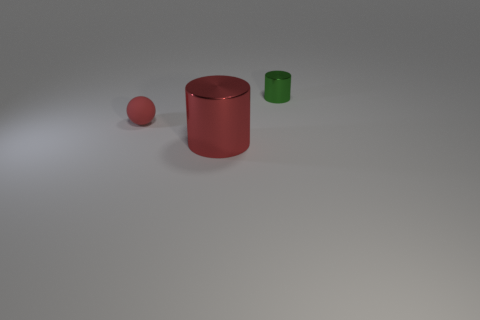Add 1 big red things. How many objects exist? 4 Subtract all spheres. How many objects are left? 2 Add 3 blue things. How many blue things exist? 3 Subtract 1 red spheres. How many objects are left? 2 Subtract all tiny rubber things. Subtract all metallic cylinders. How many objects are left? 0 Add 1 metal cylinders. How many metal cylinders are left? 3 